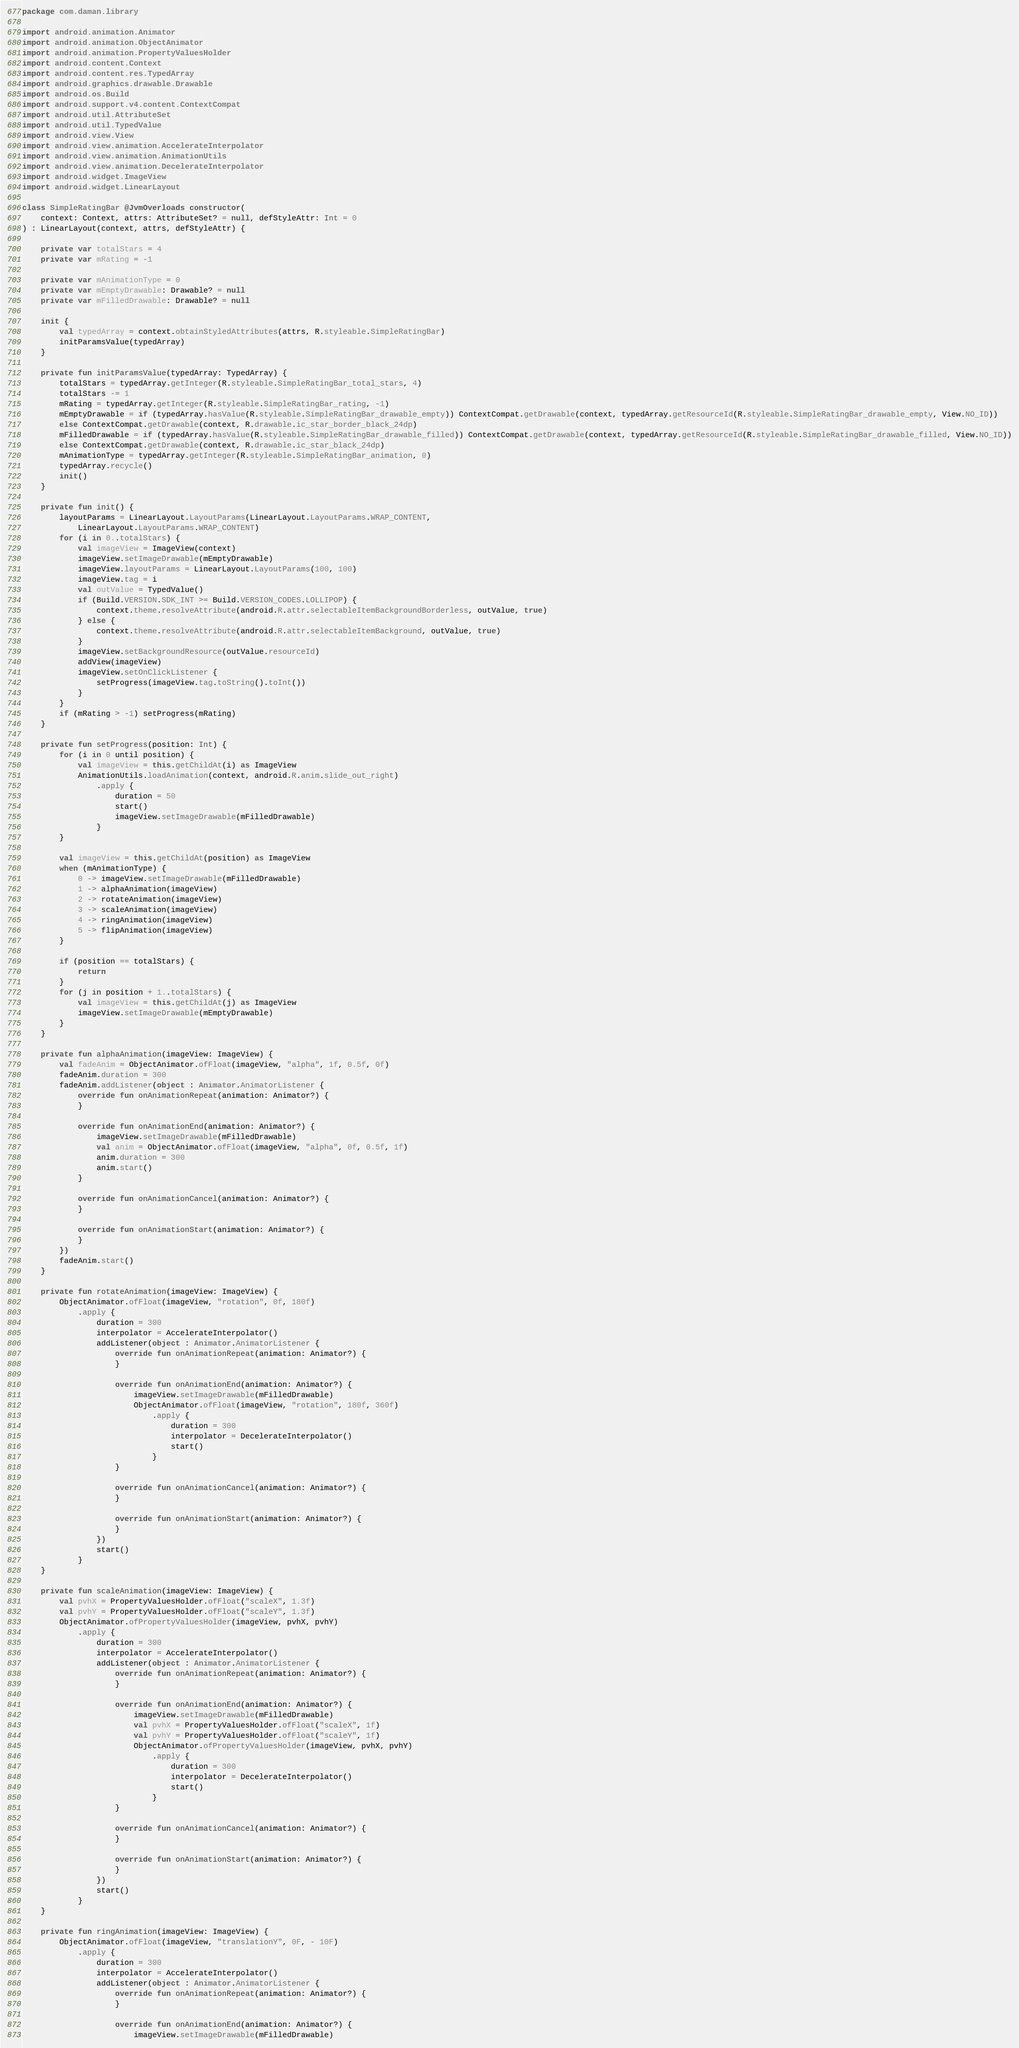<code> <loc_0><loc_0><loc_500><loc_500><_Kotlin_>package com.daman.library

import android.animation.Animator
import android.animation.ObjectAnimator
import android.animation.PropertyValuesHolder
import android.content.Context
import android.content.res.TypedArray
import android.graphics.drawable.Drawable
import android.os.Build
import android.support.v4.content.ContextCompat
import android.util.AttributeSet
import android.util.TypedValue
import android.view.View
import android.view.animation.AccelerateInterpolator
import android.view.animation.AnimationUtils
import android.view.animation.DecelerateInterpolator
import android.widget.ImageView
import android.widget.LinearLayout

class SimpleRatingBar @JvmOverloads constructor(
    context: Context, attrs: AttributeSet? = null, defStyleAttr: Int = 0
) : LinearLayout(context, attrs, defStyleAttr) {

    private var totalStars = 4
    private var mRating = -1

    private var mAnimationType = 0
    private var mEmptyDrawable: Drawable? = null
    private var mFilledDrawable: Drawable? = null

    init {
        val typedArray = context.obtainStyledAttributes(attrs, R.styleable.SimpleRatingBar)
        initParamsValue(typedArray)
    }

    private fun initParamsValue(typedArray: TypedArray) {
        totalStars = typedArray.getInteger(R.styleable.SimpleRatingBar_total_stars, 4)
        totalStars -= 1
        mRating = typedArray.getInteger(R.styleable.SimpleRatingBar_rating, -1)
        mEmptyDrawable = if (typedArray.hasValue(R.styleable.SimpleRatingBar_drawable_empty)) ContextCompat.getDrawable(context, typedArray.getResourceId(R.styleable.SimpleRatingBar_drawable_empty, View.NO_ID))
        else ContextCompat.getDrawable(context, R.drawable.ic_star_border_black_24dp)
        mFilledDrawable = if (typedArray.hasValue(R.styleable.SimpleRatingBar_drawable_filled)) ContextCompat.getDrawable(context, typedArray.getResourceId(R.styleable.SimpleRatingBar_drawable_filled, View.NO_ID))
        else ContextCompat.getDrawable(context, R.drawable.ic_star_black_24dp)
        mAnimationType = typedArray.getInteger(R.styleable.SimpleRatingBar_animation, 0)
        typedArray.recycle()
        init()
    }

    private fun init() {
        layoutParams = LinearLayout.LayoutParams(LinearLayout.LayoutParams.WRAP_CONTENT,
            LinearLayout.LayoutParams.WRAP_CONTENT)
        for (i in 0..totalStars) {
            val imageView = ImageView(context)
            imageView.setImageDrawable(mEmptyDrawable)
            imageView.layoutParams = LinearLayout.LayoutParams(100, 100)
            imageView.tag = i
            val outValue = TypedValue()
            if (Build.VERSION.SDK_INT >= Build.VERSION_CODES.LOLLIPOP) {
                context.theme.resolveAttribute(android.R.attr.selectableItemBackgroundBorderless, outValue, true)
            } else {
                context.theme.resolveAttribute(android.R.attr.selectableItemBackground, outValue, true)
            }
            imageView.setBackgroundResource(outValue.resourceId)
            addView(imageView)
            imageView.setOnClickListener {
                setProgress(imageView.tag.toString().toInt())
            }
        }
        if (mRating > -1) setProgress(mRating)
    }

    private fun setProgress(position: Int) {
        for (i in 0 until position) {
            val imageView = this.getChildAt(i) as ImageView
            AnimationUtils.loadAnimation(context, android.R.anim.slide_out_right)
                .apply {
                    duration = 50
                    start()
                    imageView.setImageDrawable(mFilledDrawable)
                }
        }

        val imageView = this.getChildAt(position) as ImageView
        when (mAnimationType) {
            0 -> imageView.setImageDrawable(mFilledDrawable)
            1 -> alphaAnimation(imageView)
            2 -> rotateAnimation(imageView)
            3 -> scaleAnimation(imageView)
            4 -> ringAnimation(imageView)
            5 -> flipAnimation(imageView)
        }

        if (position == totalStars) {
            return
        }
        for (j in position + 1..totalStars) {
            val imageView = this.getChildAt(j) as ImageView
            imageView.setImageDrawable(mEmptyDrawable)
        }
    }

    private fun alphaAnimation(imageView: ImageView) {
        val fadeAnim = ObjectAnimator.ofFloat(imageView, "alpha", 1f, 0.5f, 0f)
        fadeAnim.duration = 300
        fadeAnim.addListener(object : Animator.AnimatorListener {
            override fun onAnimationRepeat(animation: Animator?) {
            }

            override fun onAnimationEnd(animation: Animator?) {
                imageView.setImageDrawable(mFilledDrawable)
                val anim = ObjectAnimator.ofFloat(imageView, "alpha", 0f, 0.5f, 1f)
                anim.duration = 300
                anim.start()
            }

            override fun onAnimationCancel(animation: Animator?) {
            }

            override fun onAnimationStart(animation: Animator?) {
            }
        })
        fadeAnim.start()
    }

    private fun rotateAnimation(imageView: ImageView) {
        ObjectAnimator.ofFloat(imageView, "rotation", 0f, 180f)
            .apply {
                duration = 300
                interpolator = AccelerateInterpolator()
                addListener(object : Animator.AnimatorListener {
                    override fun onAnimationRepeat(animation: Animator?) {
                    }

                    override fun onAnimationEnd(animation: Animator?) {
                        imageView.setImageDrawable(mFilledDrawable)
                        ObjectAnimator.ofFloat(imageView, "rotation", 180f, 360f)
                            .apply {
                                duration = 300
                                interpolator = DecelerateInterpolator()
                                start()
                            }
                    }

                    override fun onAnimationCancel(animation: Animator?) {
                    }

                    override fun onAnimationStart(animation: Animator?) {
                    }
                })
                start()
            }
    }

    private fun scaleAnimation(imageView: ImageView) {
        val pvhX = PropertyValuesHolder.ofFloat("scaleX", 1.3f)
        val pvhY = PropertyValuesHolder.ofFloat("scaleY", 1.3f)
        ObjectAnimator.ofPropertyValuesHolder(imageView, pvhX, pvhY)
            .apply {
                duration = 300
                interpolator = AccelerateInterpolator()
                addListener(object : Animator.AnimatorListener {
                    override fun onAnimationRepeat(animation: Animator?) {
                    }

                    override fun onAnimationEnd(animation: Animator?) {
                        imageView.setImageDrawable(mFilledDrawable)
                        val pvhX = PropertyValuesHolder.ofFloat("scaleX", 1f)
                        val pvhY = PropertyValuesHolder.ofFloat("scaleY", 1f)
                        ObjectAnimator.ofPropertyValuesHolder(imageView, pvhX, pvhY)
                            .apply {
                                duration = 300
                                interpolator = DecelerateInterpolator()
                                start()
                            }
                    }

                    override fun onAnimationCancel(animation: Animator?) {
                    }

                    override fun onAnimationStart(animation: Animator?) {
                    }
                })
                start()
            }
    }

    private fun ringAnimation(imageView: ImageView) {
        ObjectAnimator.ofFloat(imageView, "translationY", 0F, - 10F)
            .apply {
                duration = 300
                interpolator = AccelerateInterpolator()
                addListener(object : Animator.AnimatorListener {
                    override fun onAnimationRepeat(animation: Animator?) {
                    }

                    override fun onAnimationEnd(animation: Animator?) {
                        imageView.setImageDrawable(mFilledDrawable)</code> 